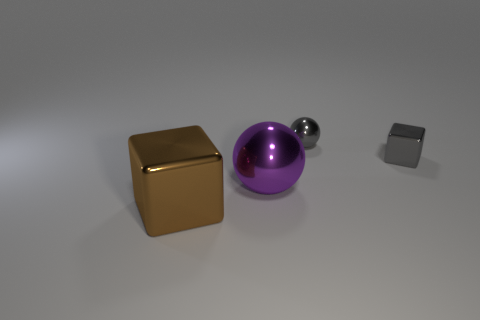Is the big thing that is behind the big brown object made of the same material as the small object behind the small metallic cube?
Your answer should be compact. Yes. There is a tiny gray object that is to the left of the small metallic thing that is in front of the gray object on the left side of the gray metallic block; what shape is it?
Your answer should be very brief. Sphere. How many gray things have the same material as the large purple thing?
Make the answer very short. 2. There is a metallic cube to the right of the large sphere; how many balls are in front of it?
Your answer should be compact. 1. There is a large thing on the left side of the large purple metal object; is it the same color as the sphere behind the large purple metallic sphere?
Provide a short and direct response. No. There is a metallic thing that is both behind the big brown thing and left of the small gray ball; what shape is it?
Your answer should be very brief. Sphere. Is there a blue rubber object of the same shape as the brown thing?
Give a very brief answer. No. There is another shiny thing that is the same size as the purple shiny thing; what is its shape?
Make the answer very short. Cube. What is the material of the large sphere?
Your answer should be compact. Metal. There is a object behind the block that is right of the purple object to the right of the large brown metallic object; what size is it?
Offer a terse response. Small. 